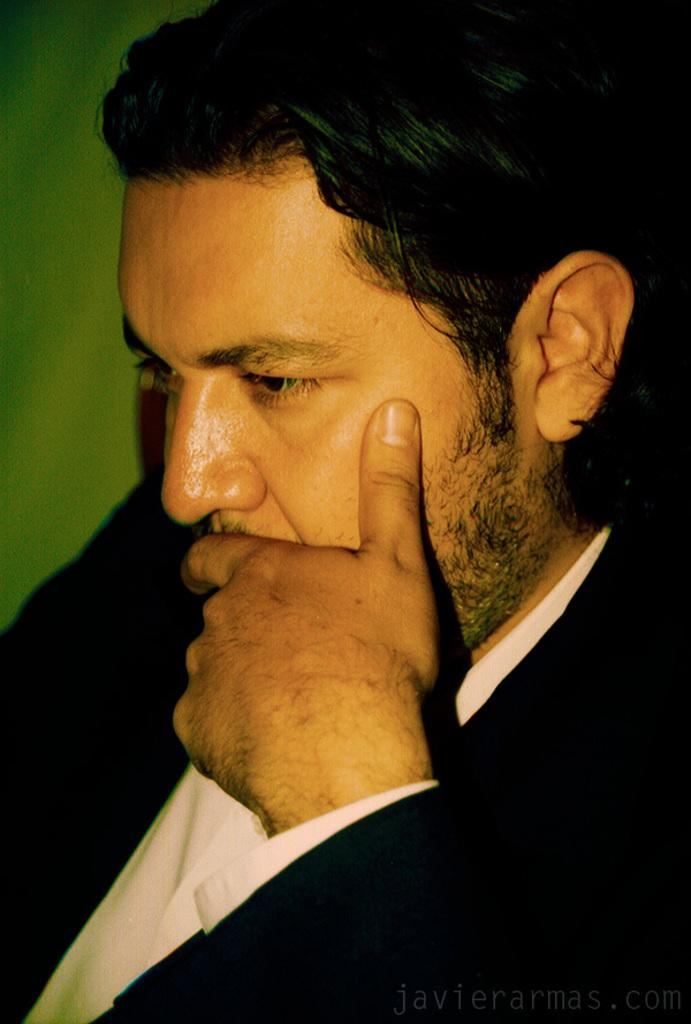Who is present in the image? There is a man in the image. What is the man wearing in the image? The man is wearing a black coat in the image. Can you describe any facial features of the man? The man has a beard in the image. What type of cable can be seen hanging from the man's beard in the image? There is no cable hanging from the man's beard in the image. 